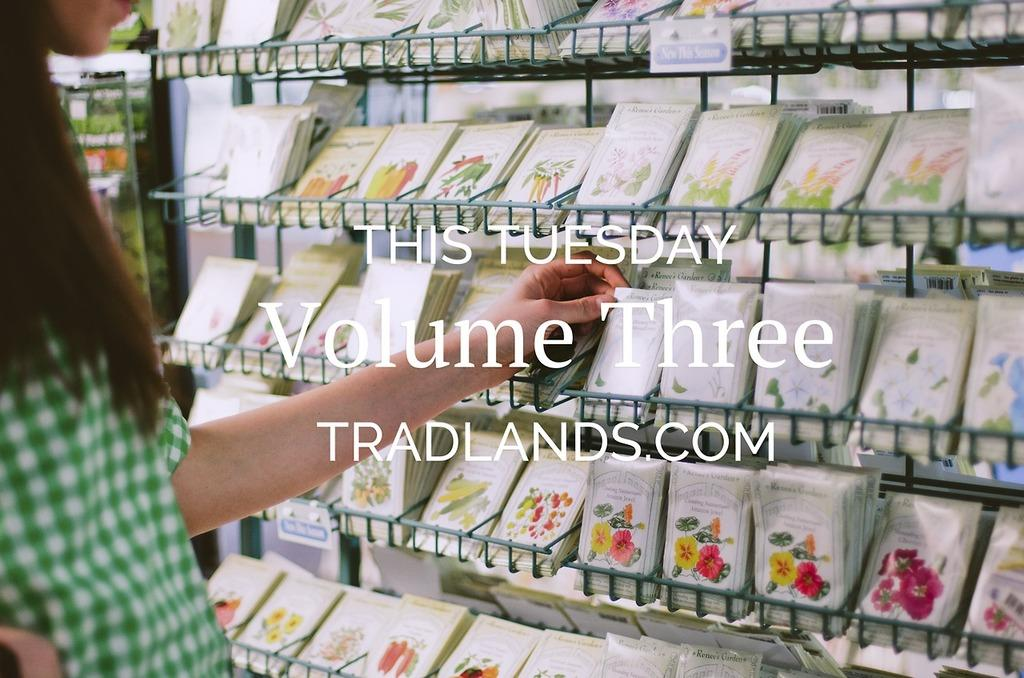<image>
Present a compact description of the photo's key features. a person looking at seed packets in front of text reading This Tuesday 